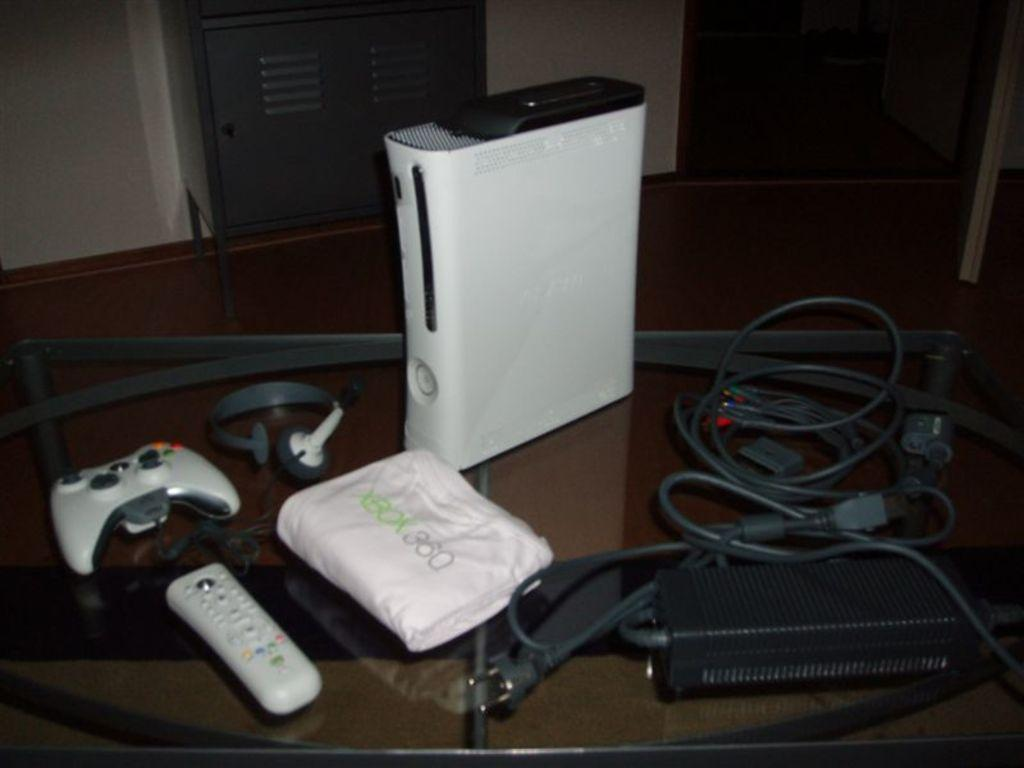<image>
Relay a brief, clear account of the picture shown. An Xbox 360 and accessories are on a glass table with a white bag that says Xbox 360. 